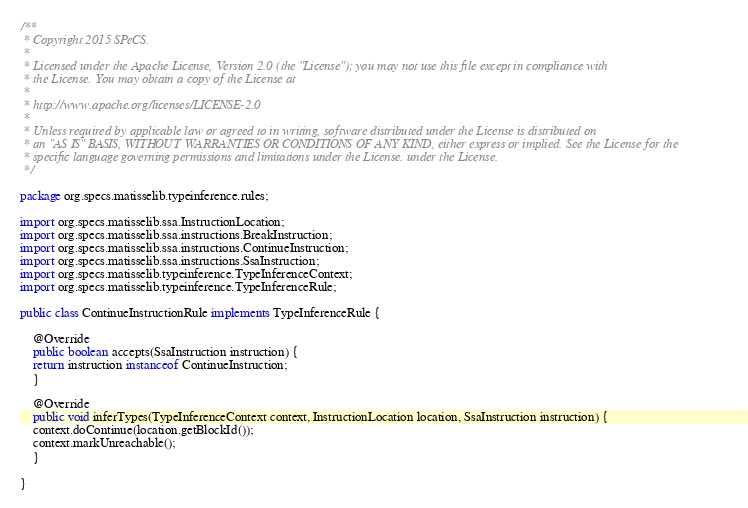Convert code to text. <code><loc_0><loc_0><loc_500><loc_500><_Java_>/**
 * Copyright 2015 SPeCS.
 * 
 * Licensed under the Apache License, Version 2.0 (the "License"); you may not use this file except in compliance with
 * the License. You may obtain a copy of the License at
 * 
 * http://www.apache.org/licenses/LICENSE-2.0
 * 
 * Unless required by applicable law or agreed to in writing, software distributed under the License is distributed on
 * an "AS IS" BASIS, WITHOUT WARRANTIES OR CONDITIONS OF ANY KIND, either express or implied. See the License for the
 * specific language governing permissions and limitations under the License. under the License.
 */

package org.specs.matisselib.typeinference.rules;

import org.specs.matisselib.ssa.InstructionLocation;
import org.specs.matisselib.ssa.instructions.BreakInstruction;
import org.specs.matisselib.ssa.instructions.ContinueInstruction;
import org.specs.matisselib.ssa.instructions.SsaInstruction;
import org.specs.matisselib.typeinference.TypeInferenceContext;
import org.specs.matisselib.typeinference.TypeInferenceRule;

public class ContinueInstructionRule implements TypeInferenceRule {

    @Override
    public boolean accepts(SsaInstruction instruction) {
	return instruction instanceof ContinueInstruction;
    }

    @Override
    public void inferTypes(TypeInferenceContext context, InstructionLocation location, SsaInstruction instruction) {
	context.doContinue(location.getBlockId());
	context.markUnreachable();
    }

}
</code> 